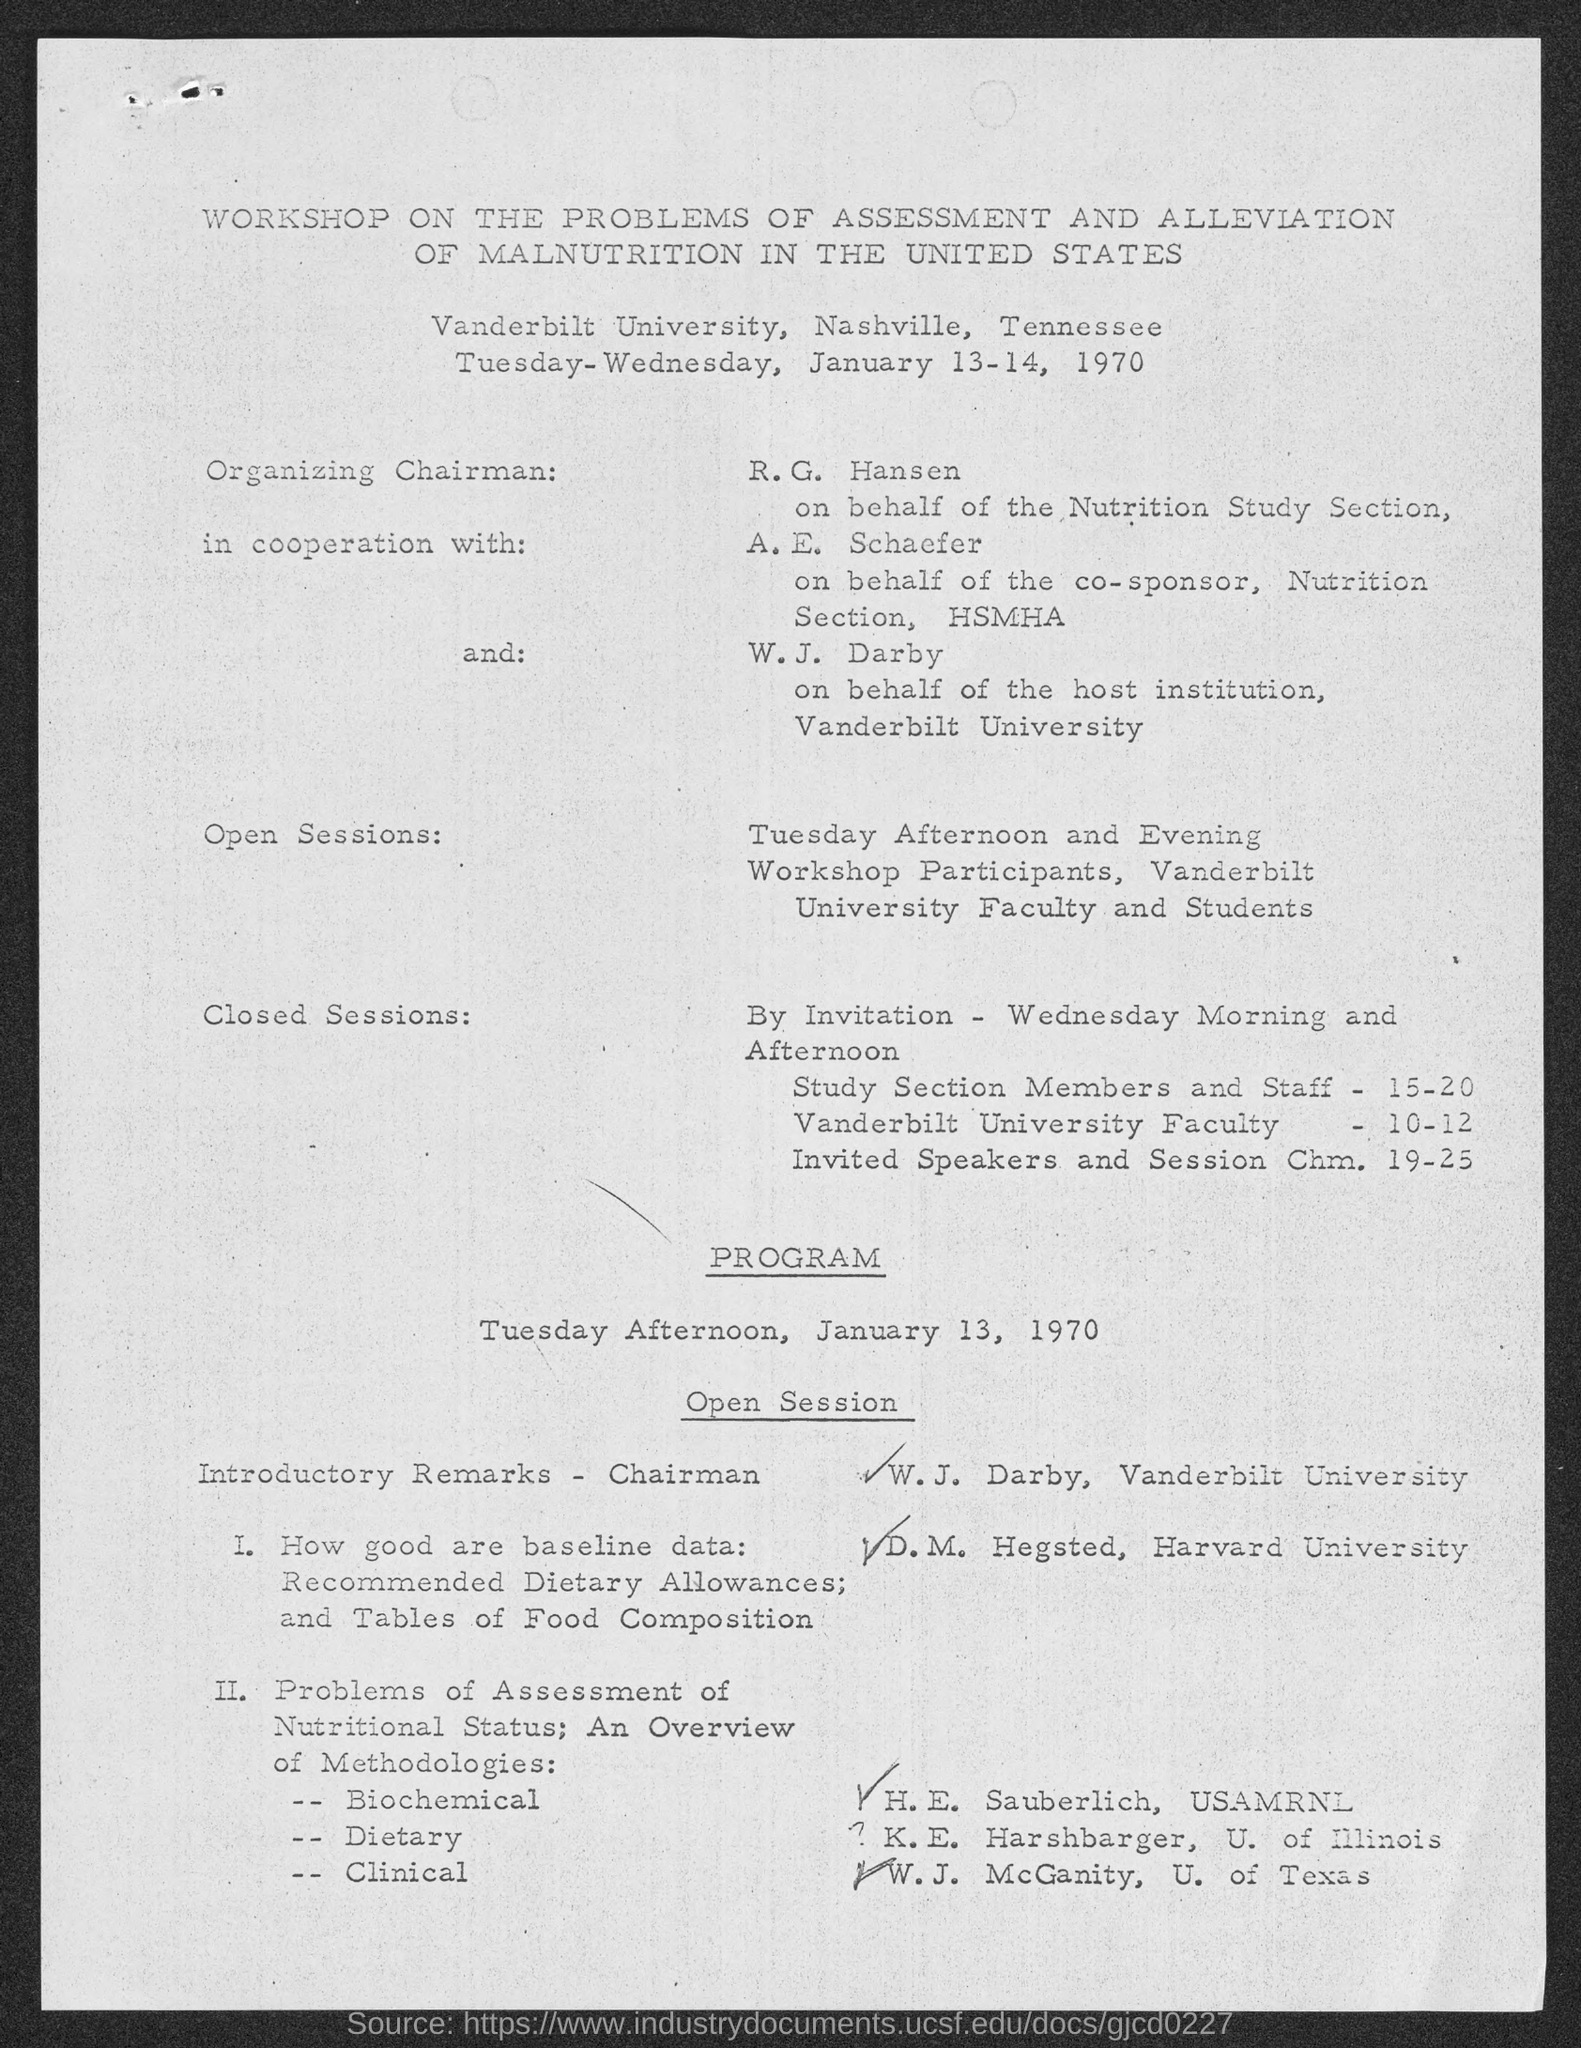When is the Workshop on the problems of Assessment and Alleviation of Malnutrition in the United States held?
Make the answer very short. Tuesday-Wednesday, January 13-14, 1970. Where is the Workshop on the problems of Assessment and Alleviation of Malnutrition in the United States held?
Offer a very short reply. Vanderbilt University, Nashville, Tennessee. 